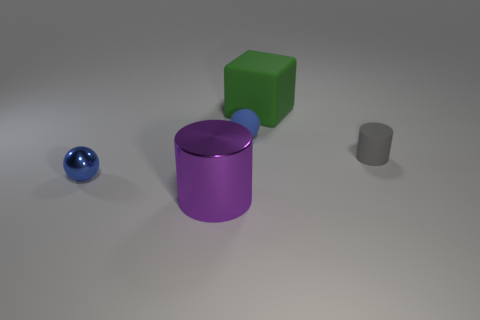How many rubber blocks are the same color as the rubber ball? 0 